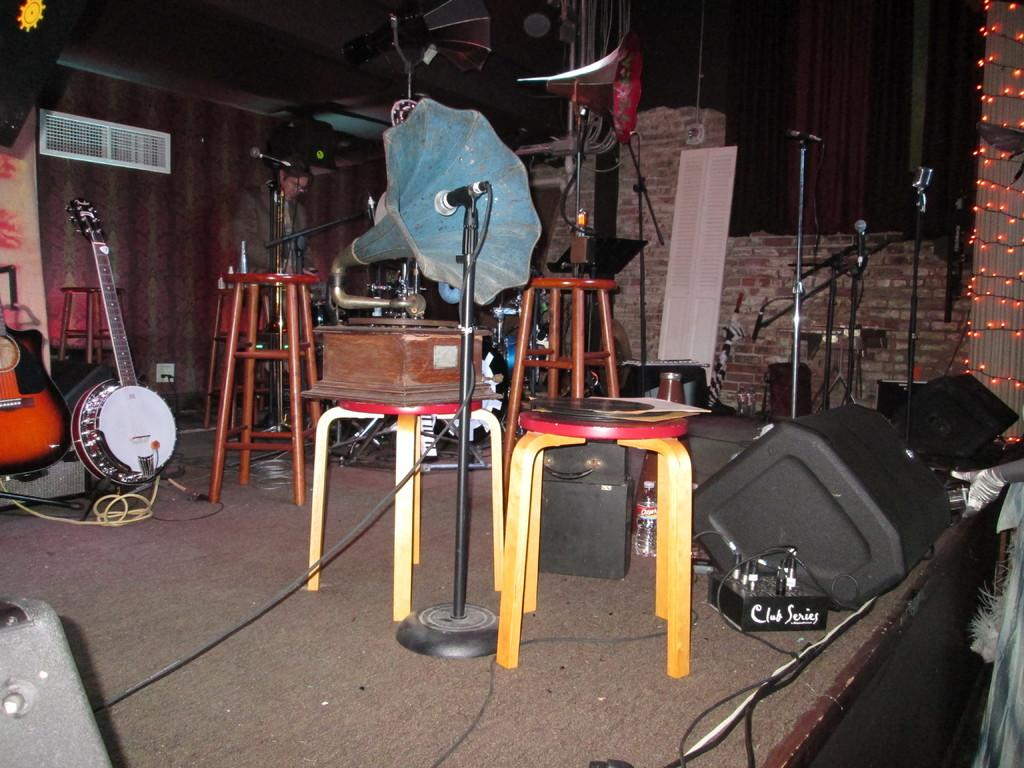What objects are present in the image related to music? There are different music instruments and speakers in the image. What type of furniture is in the image? There are stools in the image. Can you describe the background of the image? There is a person standing in the background and a wall in the background of the image. How long does it take for the person to take a bath in the image? There is no indication of a bath or any person taking a bath in the image. What trick can be performed with the music instruments in the image? There is no trick being performed with the music instruments in the image; they are simply present. 